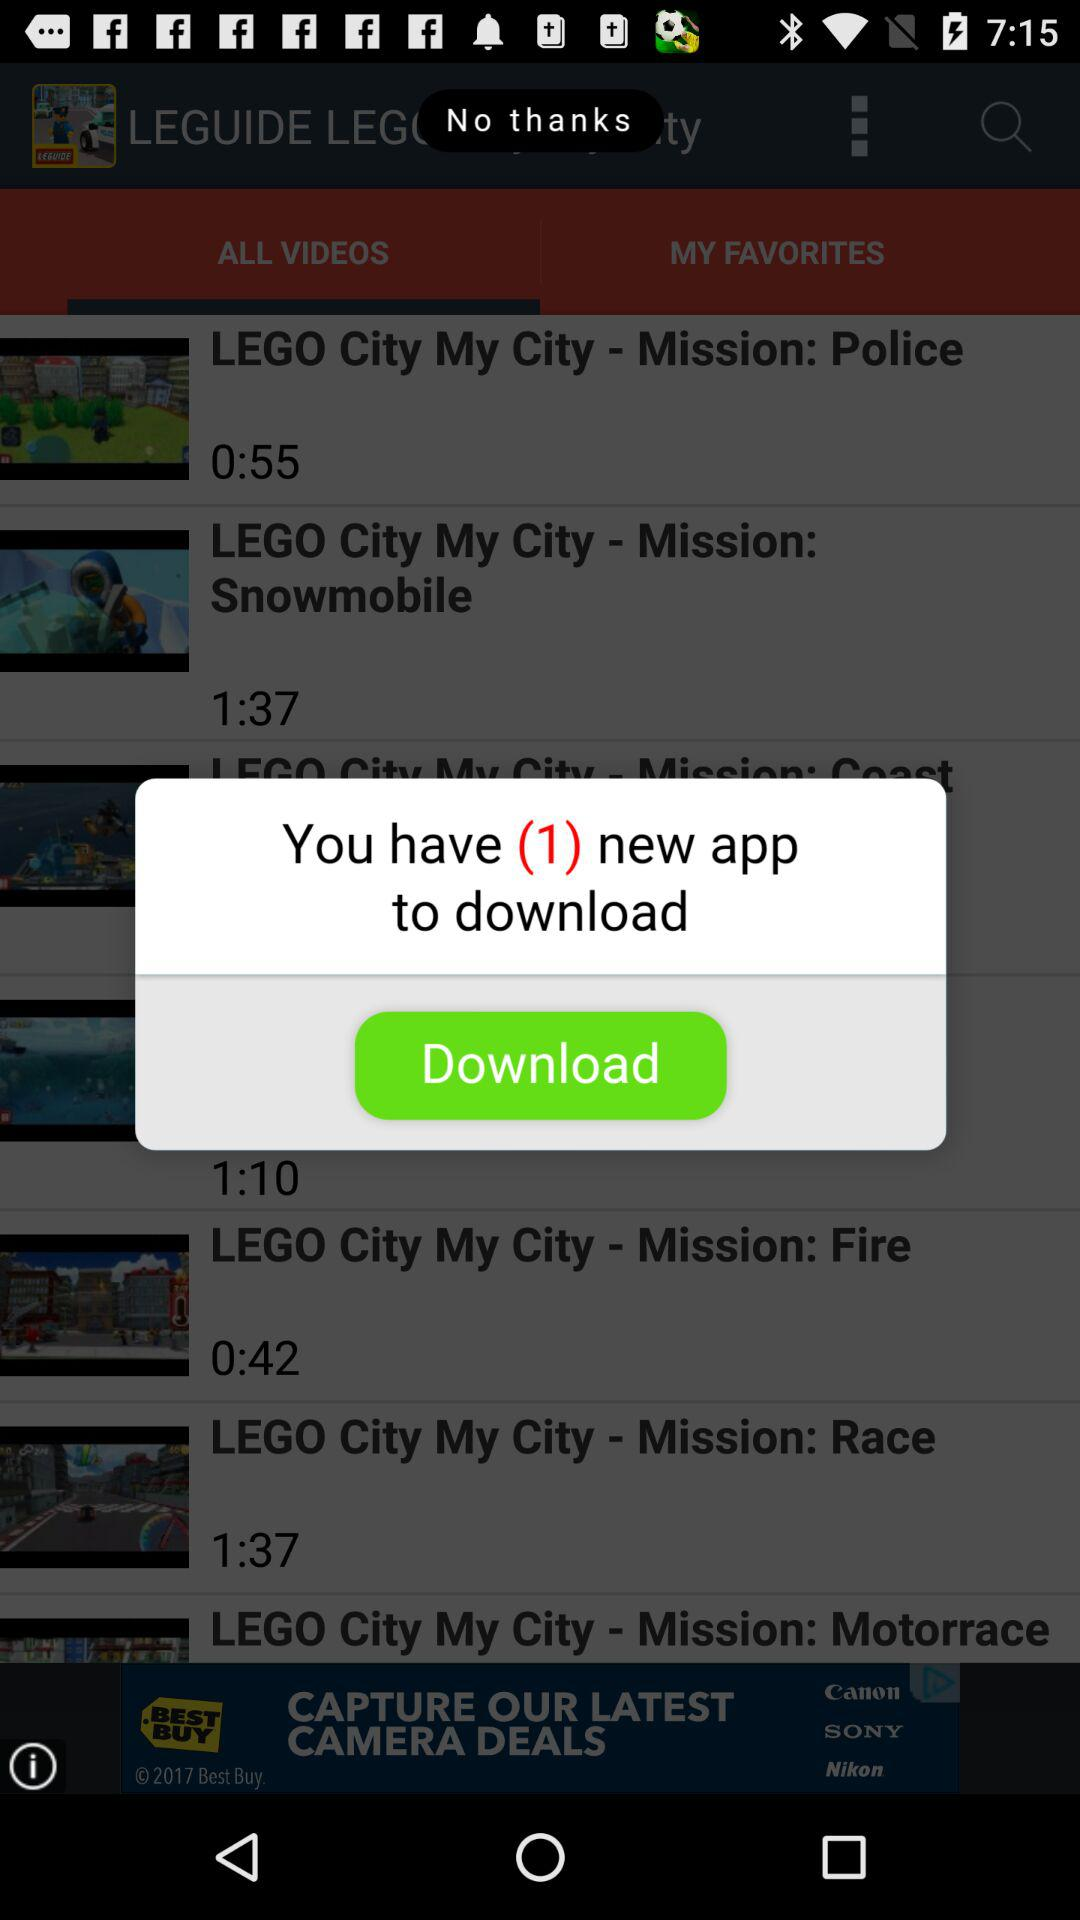How many new applications to download? There is only 1 new application to download. 